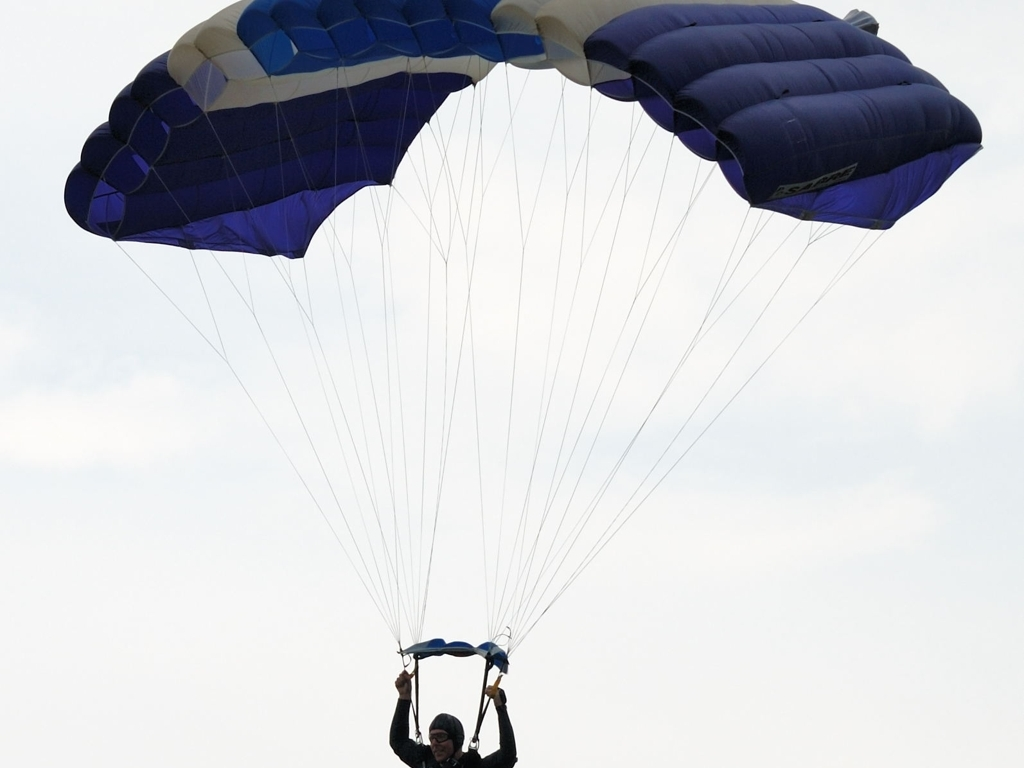What does this image reveal about the activity of paragliding? This image provides a glimpse into the adventurous and thrilling world of paragliding. The clear sky and the position of the paraglider emphasize a sense of freedom and height associated with the sport. It's a solitary activity up in the air, showcasing the paraglider in a calm posture, suggesting a blend of serenity and adrenaline. Additionally, the image captures the crucial aspect of control in paragliding, as the paraglider holds the handles to navigate the canopy. 